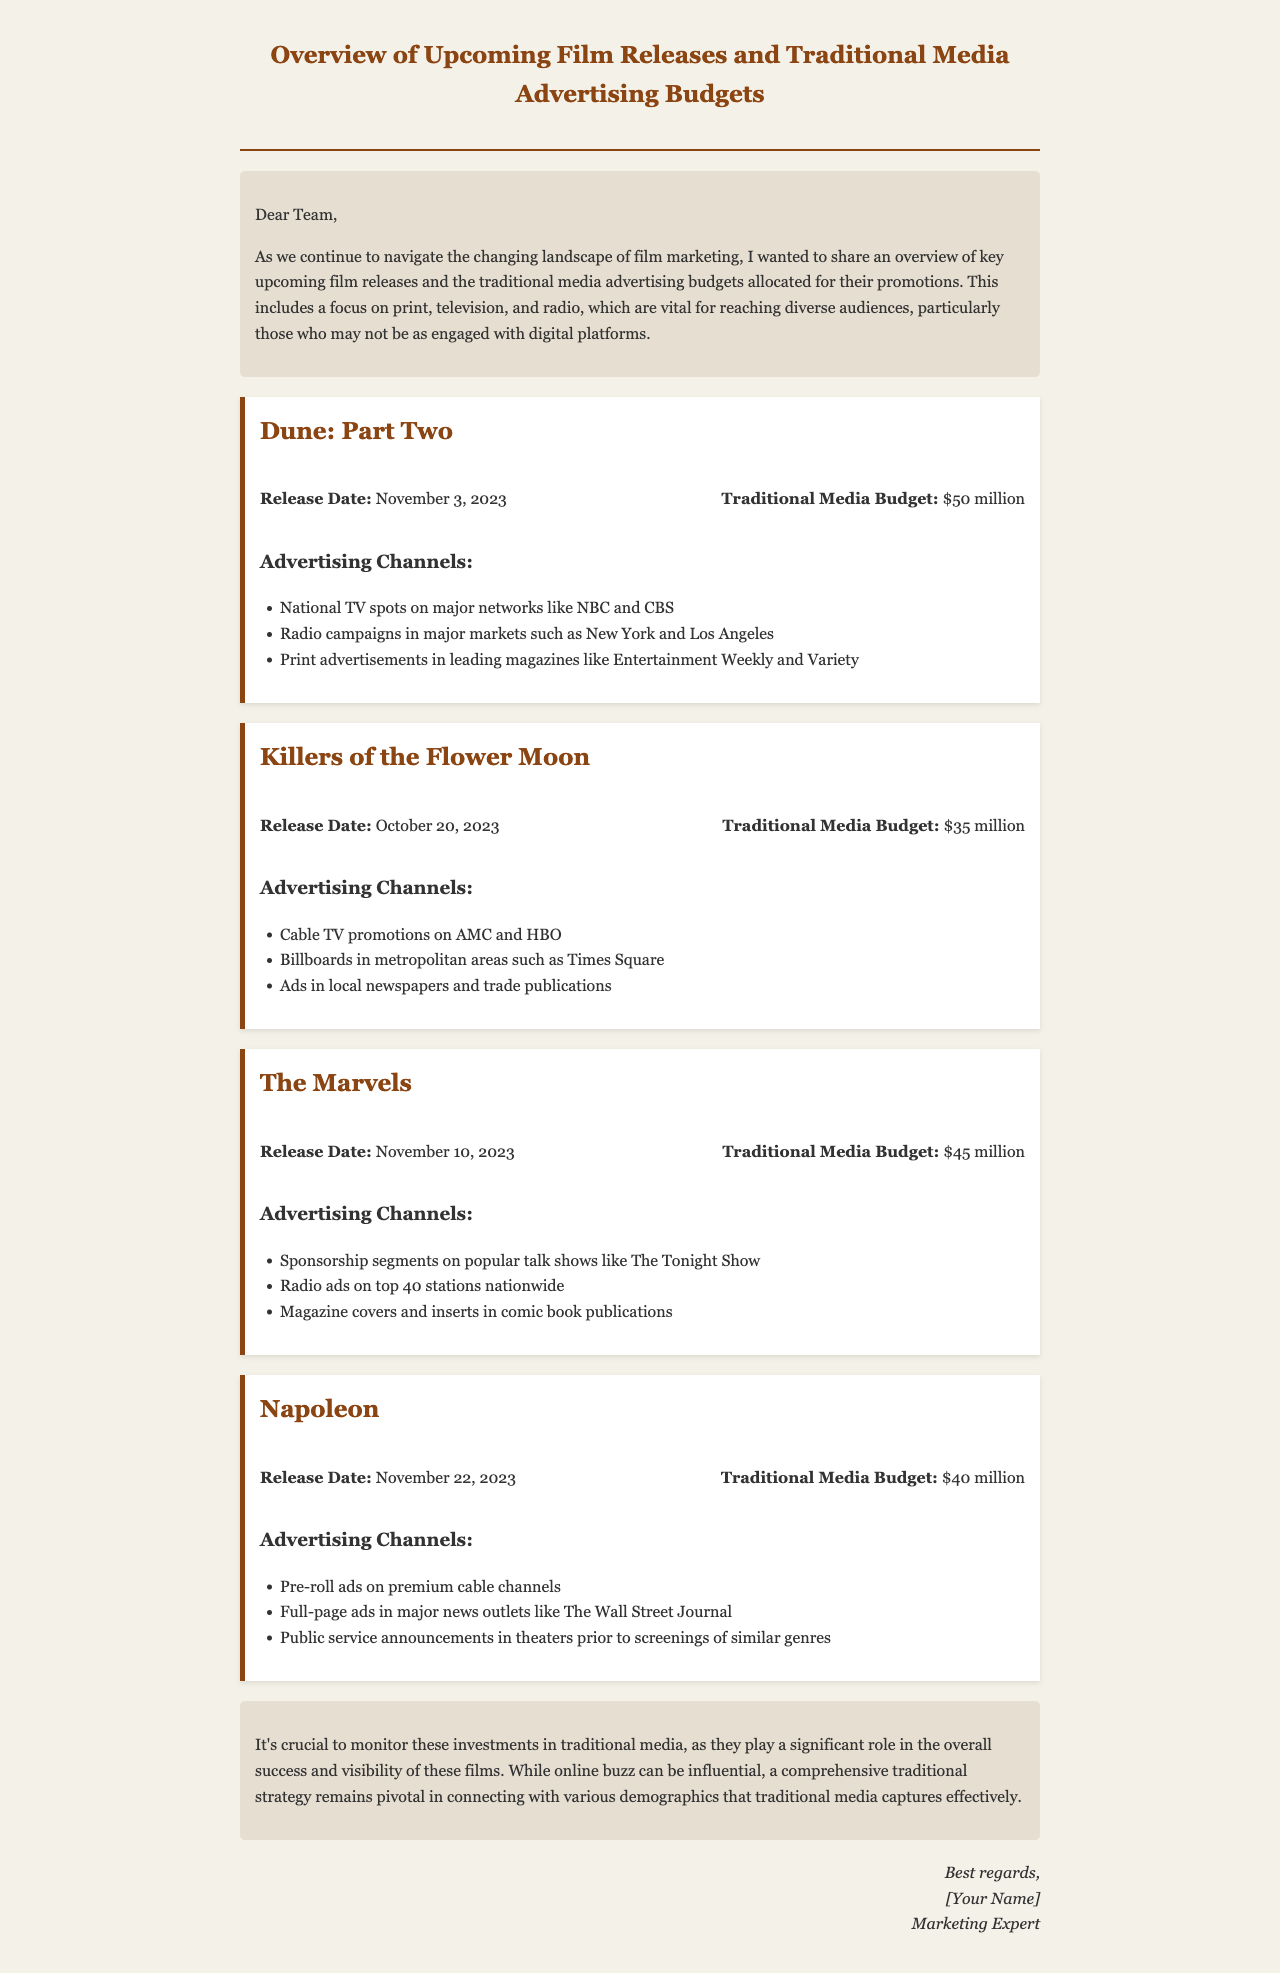What is the release date of Dune: Part Two? The release date is stated in the details of Dune: Part Two.
Answer: November 3, 2023 What is the traditional media budget for Killers of the Flower Moon? The budget for Killers of the Flower Moon is specified within its section of the document.
Answer: $35 million Which advertising channel is mentioned for The Marvels? An advertising channel for The Marvels is included in its promotional details in the document.
Answer: Sponsorship segments on popular talk shows How much is allocated for Napoleon's traditional media advertising? The budget for Napoleon's advertising is noted in the section detailing the film's finances.
Answer: $40 million Which cities are mentioned for radio campaigns for Dune: Part Two? The cities for radio campaigns are provided in the advertising channels section of Dune: Part Two.
Answer: New York and Los Angeles What is the total traditional media budget for all the films listed? The total budget is calculated by summing all individual budgets provided for each film.
Answer: $170 million What is emphasized as vital despite the online buzz? The conclusion highlights the importance of certain media strategies that remain crucial for film success.
Answer: Traditional media strategy What type of content is this document? The document serves a specific purpose in film marketing insights and budget allocations.
Answer: Overview email 